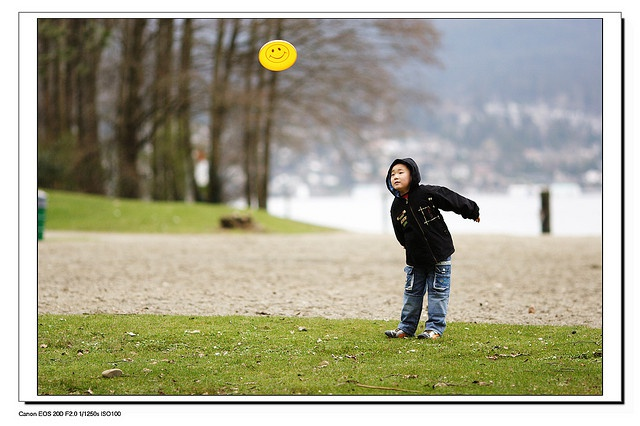Describe the objects in this image and their specific colors. I can see people in white, black, gray, and lightgray tones and frisbee in white, gold, orange, ivory, and gray tones in this image. 